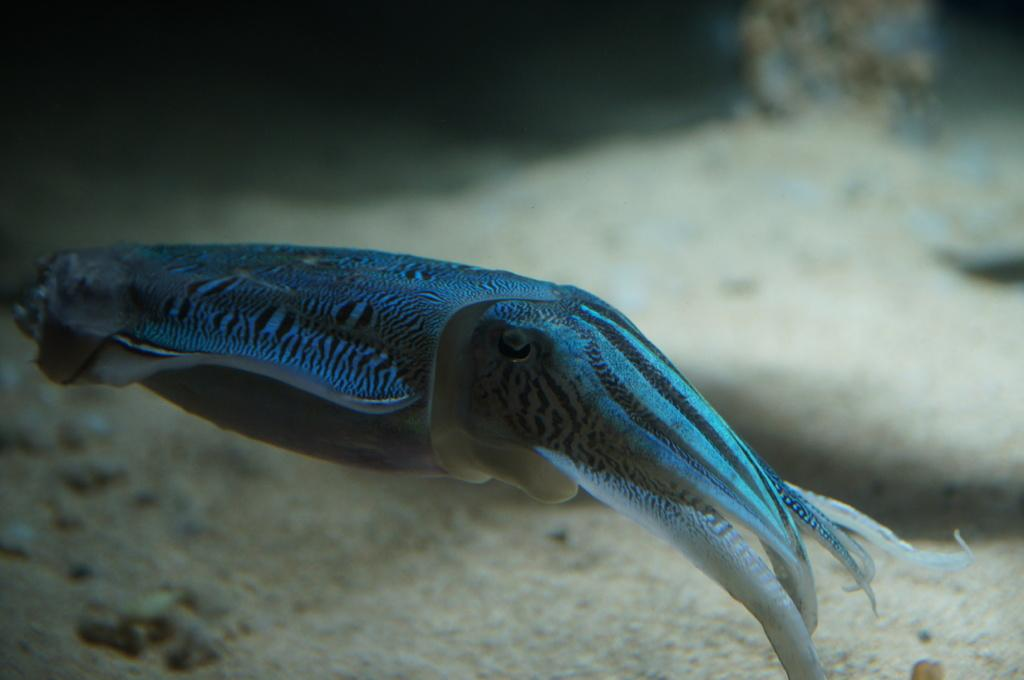What type of animal can be seen in the image? There is a water animal in the image. Where is the water animal located? The water animal is in the water. What can be found at the bottom of the image? There is sand and stones at the bottom of the image. What is the taste of the root in the image? There is no root present in the image, so it is not possible to determine its taste. 